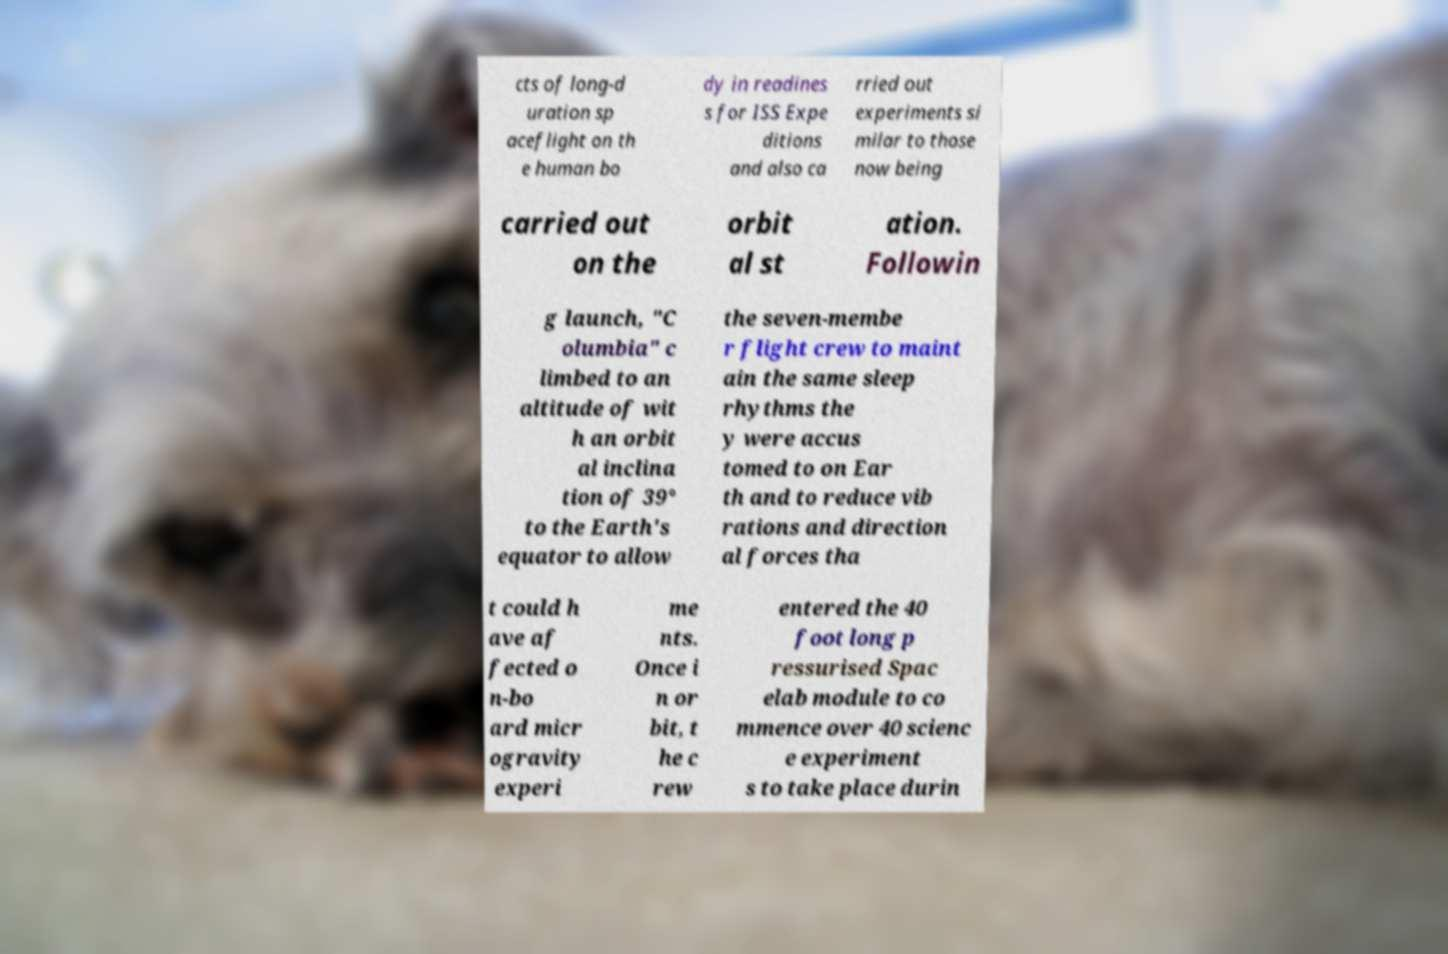Can you read and provide the text displayed in the image?This photo seems to have some interesting text. Can you extract and type it out for me? cts of long-d uration sp aceflight on th e human bo dy in readines s for ISS Expe ditions and also ca rried out experiments si milar to those now being carried out on the orbit al st ation. Followin g launch, "C olumbia" c limbed to an altitude of wit h an orbit al inclina tion of 39° to the Earth's equator to allow the seven-membe r flight crew to maint ain the same sleep rhythms the y were accus tomed to on Ear th and to reduce vib rations and direction al forces tha t could h ave af fected o n-bo ard micr ogravity experi me nts. Once i n or bit, t he c rew entered the 40 foot long p ressurised Spac elab module to co mmence over 40 scienc e experiment s to take place durin 